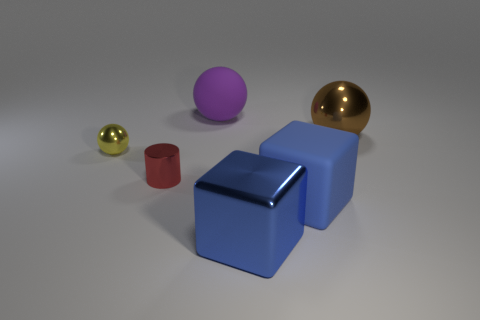Subtract all small yellow metal spheres. How many spheres are left? 2 Subtract all cylinders. How many objects are left? 5 Add 2 yellow metal cylinders. How many objects exist? 8 Subtract all red balls. Subtract all brown cylinders. How many balls are left? 3 Subtract all yellow cylinders. How many brown spheres are left? 1 Subtract all tiny red cylinders. Subtract all small yellow shiny objects. How many objects are left? 4 Add 1 big rubber balls. How many big rubber balls are left? 2 Add 2 matte things. How many matte things exist? 4 Subtract all brown balls. How many balls are left? 2 Subtract 0 blue cylinders. How many objects are left? 6 